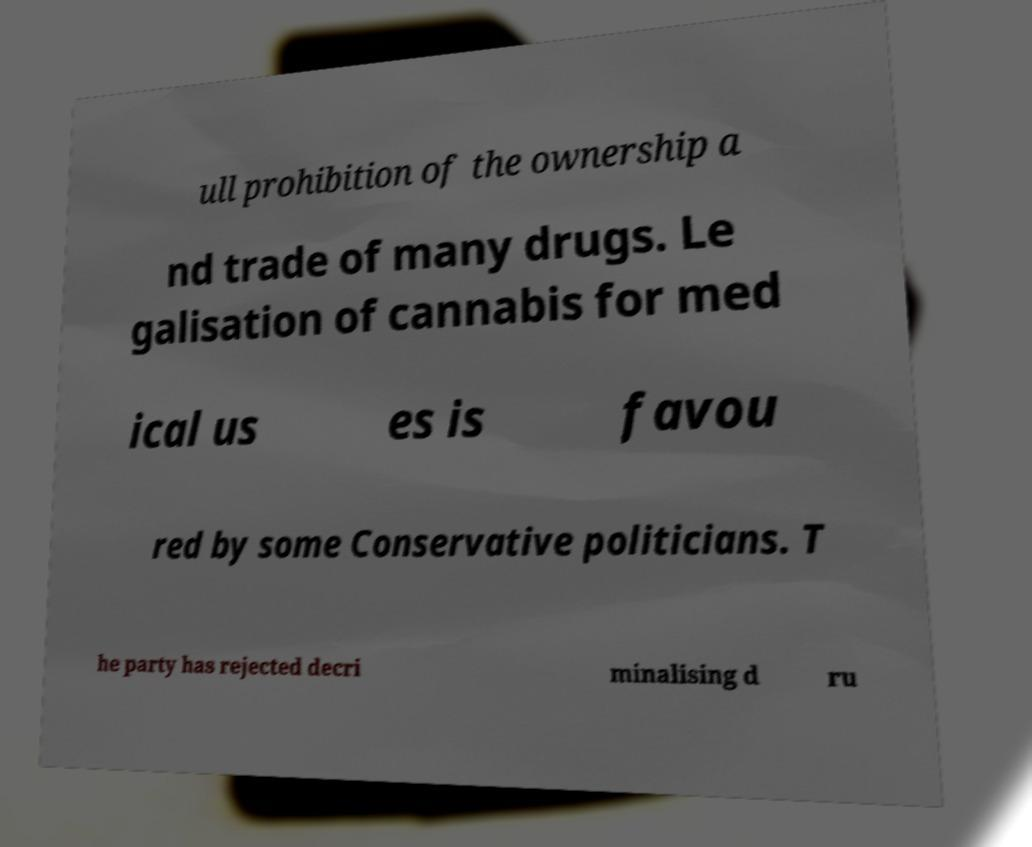What messages or text are displayed in this image? I need them in a readable, typed format. ull prohibition of the ownership a nd trade of many drugs. Le galisation of cannabis for med ical us es is favou red by some Conservative politicians. T he party has rejected decri minalising d ru 